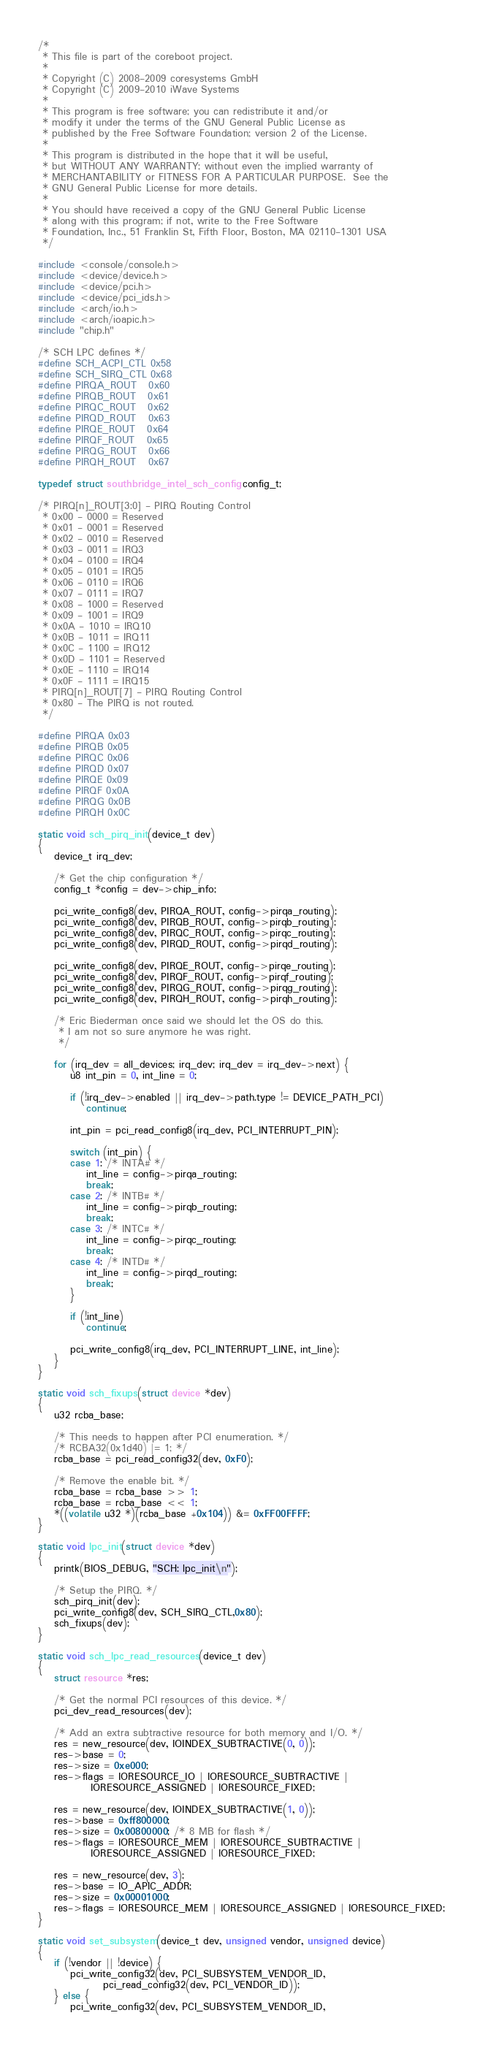<code> <loc_0><loc_0><loc_500><loc_500><_C_>/*
 * This file is part of the coreboot project.
 *
 * Copyright (C) 2008-2009 coresystems GmbH
 * Copyright (C) 2009-2010 iWave Systems
 *
 * This program is free software; you can redistribute it and/or
 * modify it under the terms of the GNU General Public License as
 * published by the Free Software Foundation; version 2 of the License.
 *
 * This program is distributed in the hope that it will be useful,
 * but WITHOUT ANY WARRANTY; without even the implied warranty of
 * MERCHANTABILITY or FITNESS FOR A PARTICULAR PURPOSE.  See the
 * GNU General Public License for more details.
 *
 * You should have received a copy of the GNU General Public License
 * along with this program; if not, write to the Free Software
 * Foundation, Inc., 51 Franklin St, Fifth Floor, Boston, MA 02110-1301 USA
 */

#include <console/console.h>
#include <device/device.h>
#include <device/pci.h>
#include <device/pci_ids.h>
#include <arch/io.h>
#include <arch/ioapic.h>
#include "chip.h"

/* SCH LPC defines */
#define SCH_ACPI_CTL	0x58
#define SCH_SIRQ_CTL	0x68
#define PIRQA_ROUT	0x60
#define PIRQB_ROUT	0x61
#define PIRQC_ROUT	0x62
#define PIRQD_ROUT	0x63
#define PIRQE_ROUT	0x64
#define PIRQF_ROUT	0x65
#define PIRQG_ROUT	0x66
#define PIRQH_ROUT	0x67

typedef struct southbridge_intel_sch_config config_t;

/* PIRQ[n]_ROUT[3:0] - PIRQ Routing Control
 * 0x00 - 0000 = Reserved
 * 0x01 - 0001 = Reserved
 * 0x02 - 0010 = Reserved
 * 0x03 - 0011 = IRQ3
 * 0x04 - 0100 = IRQ4
 * 0x05 - 0101 = IRQ5
 * 0x06 - 0110 = IRQ6
 * 0x07 - 0111 = IRQ7
 * 0x08 - 1000 = Reserved
 * 0x09 - 1001 = IRQ9
 * 0x0A - 1010 = IRQ10
 * 0x0B - 1011 = IRQ11
 * 0x0C - 1100 = IRQ12
 * 0x0D - 1101 = Reserved
 * 0x0E - 1110 = IRQ14
 * 0x0F - 1111 = IRQ15
 * PIRQ[n]_ROUT[7] - PIRQ Routing Control
 * 0x80 - The PIRQ is not routed.
 */

#define PIRQA 0x03
#define PIRQB 0x05
#define PIRQC 0x06
#define PIRQD 0x07
#define PIRQE 0x09
#define PIRQF 0x0A
#define PIRQG 0x0B
#define PIRQH 0x0C

static void sch_pirq_init(device_t dev)
{
	device_t irq_dev;

	/* Get the chip configuration */
	config_t *config = dev->chip_info;

	pci_write_config8(dev, PIRQA_ROUT, config->pirqa_routing);
	pci_write_config8(dev, PIRQB_ROUT, config->pirqb_routing);
	pci_write_config8(dev, PIRQC_ROUT, config->pirqc_routing);
	pci_write_config8(dev, PIRQD_ROUT, config->pirqd_routing);

	pci_write_config8(dev, PIRQE_ROUT, config->pirqe_routing);
	pci_write_config8(dev, PIRQF_ROUT, config->pirqf_routing);
	pci_write_config8(dev, PIRQG_ROUT, config->pirqg_routing);
	pci_write_config8(dev, PIRQH_ROUT, config->pirqh_routing);

	/* Eric Biederman once said we should let the OS do this.
	 * I am not so sure anymore he was right.
	 */

	for (irq_dev = all_devices; irq_dev; irq_dev = irq_dev->next) {
		u8 int_pin = 0, int_line = 0;

		if (!irq_dev->enabled || irq_dev->path.type != DEVICE_PATH_PCI)
			continue;

		int_pin = pci_read_config8(irq_dev, PCI_INTERRUPT_PIN);

		switch (int_pin) {
		case 1: /* INTA# */
			int_line = config->pirqa_routing;
			break;
		case 2: /* INTB# */
			int_line = config->pirqb_routing;
			break;
		case 3: /* INTC# */
			int_line = config->pirqc_routing;
			break;
		case 4: /* INTD# */
			int_line = config->pirqd_routing;
			break;
		}

		if (!int_line)
			continue;

		pci_write_config8(irq_dev, PCI_INTERRUPT_LINE, int_line);
	}
}

static void sch_fixups(struct device *dev)
{
	u32 rcba_base;

	/* This needs to happen after PCI enumeration. */
	/* RCBA32(0x1d40) |= 1; */
	rcba_base = pci_read_config32(dev, 0xF0);

	/* Remove the enable bit. */
	rcba_base = rcba_base >> 1;
	rcba_base = rcba_base << 1;
	*((volatile u32 *)(rcba_base +0x104)) &= 0xFF00FFFF;
}

static void lpc_init(struct device *dev)
{
	printk(BIOS_DEBUG, "SCH: lpc_init\n");

	/* Setup the PIRQ. */
	sch_pirq_init(dev);
	pci_write_config8(dev, SCH_SIRQ_CTL,0x80);
	sch_fixups(dev);
}

static void sch_lpc_read_resources(device_t dev)
{
	struct resource *res;

	/* Get the normal PCI resources of this device. */
	pci_dev_read_resources(dev);

	/* Add an extra subtractive resource for both memory and I/O. */
	res = new_resource(dev, IOINDEX_SUBTRACTIVE(0, 0));
	res->base = 0;
	res->size = 0xe000;
	res->flags = IORESOURCE_IO | IORESOURCE_SUBTRACTIVE |
		     IORESOURCE_ASSIGNED | IORESOURCE_FIXED;

	res = new_resource(dev, IOINDEX_SUBTRACTIVE(1, 0));
	res->base = 0xff800000;
	res->size = 0x00800000; /* 8 MB for flash */
	res->flags = IORESOURCE_MEM | IORESOURCE_SUBTRACTIVE |
		     IORESOURCE_ASSIGNED | IORESOURCE_FIXED;

	res = new_resource(dev, 3);
	res->base = IO_APIC_ADDR;
	res->size = 0x00001000;
	res->flags = IORESOURCE_MEM | IORESOURCE_ASSIGNED | IORESOURCE_FIXED;
}

static void set_subsystem(device_t dev, unsigned vendor, unsigned device)
{
	if (!vendor || !device) {
		pci_write_config32(dev, PCI_SUBSYSTEM_VENDOR_ID,
				pci_read_config32(dev, PCI_VENDOR_ID));
	} else {
		pci_write_config32(dev, PCI_SUBSYSTEM_VENDOR_ID,</code> 